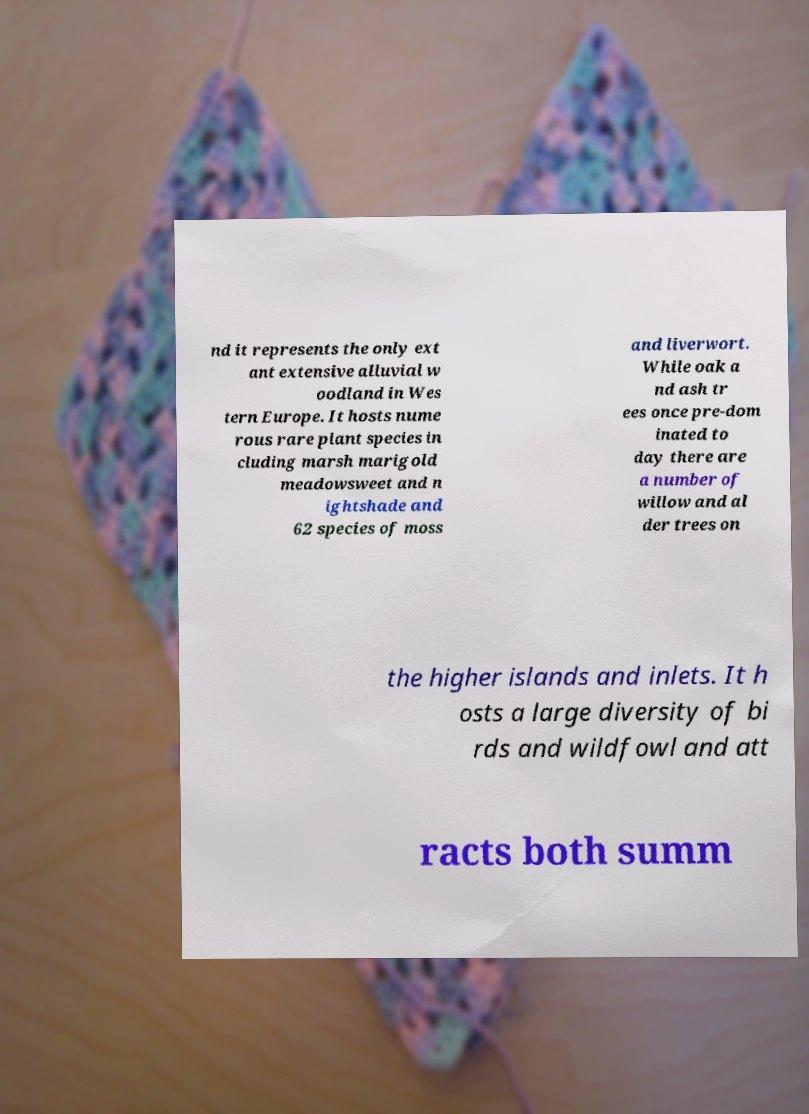What messages or text are displayed in this image? I need them in a readable, typed format. nd it represents the only ext ant extensive alluvial w oodland in Wes tern Europe. It hosts nume rous rare plant species in cluding marsh marigold meadowsweet and n ightshade and 62 species of moss and liverwort. While oak a nd ash tr ees once pre-dom inated to day there are a number of willow and al der trees on the higher islands and inlets. It h osts a large diversity of bi rds and wildfowl and att racts both summ 